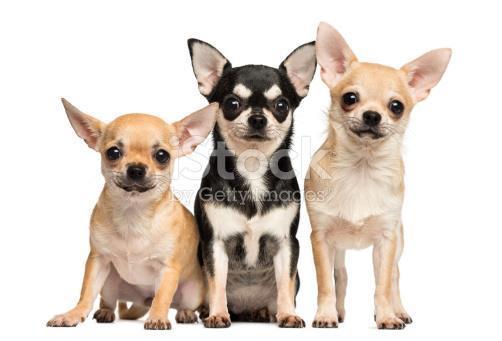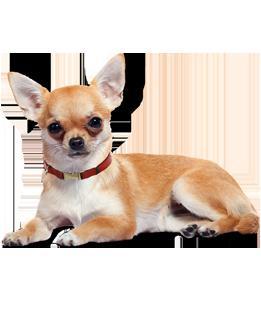The first image is the image on the left, the second image is the image on the right. For the images displayed, is the sentence "There are at least five chihuahuas." factually correct? Answer yes or no. No. The first image is the image on the left, the second image is the image on the right. Assess this claim about the two images: "The images show five dogs.". Correct or not? Answer yes or no. No. 